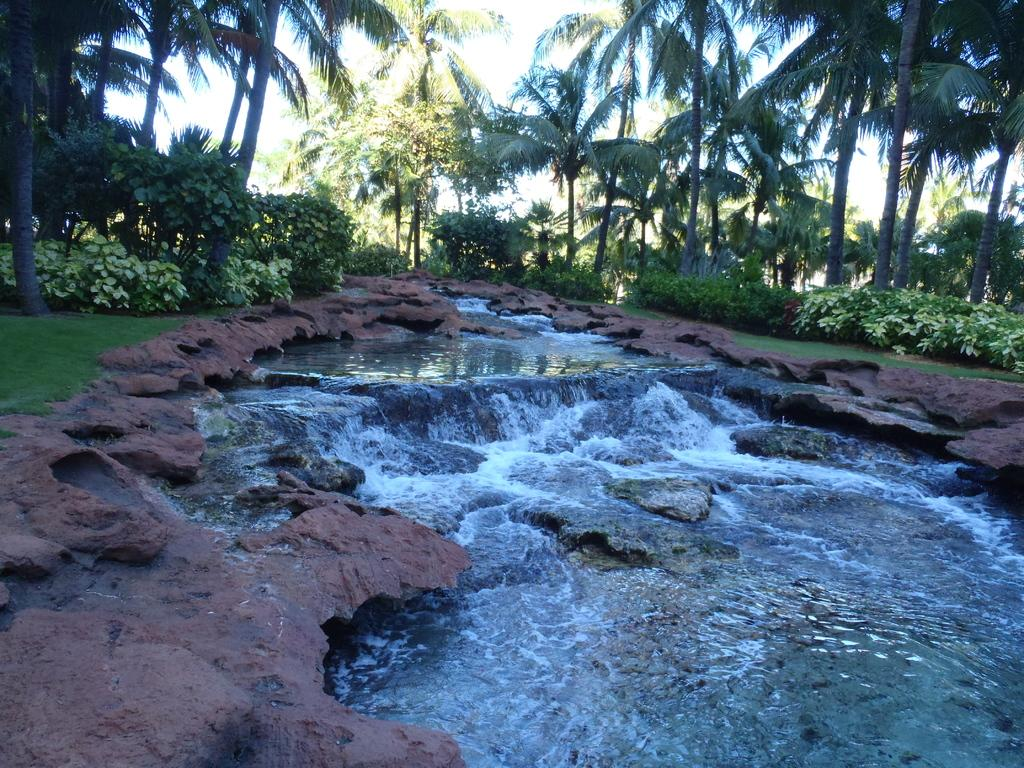What type of natural body of water is present in the image? There is a lake in the image. What type of vegetation can be seen near the lake? There is grass, plants, and trees visible in the image. How many girls are holding a bucket near the lake in the image? There are no girls or buckets present in the image. 